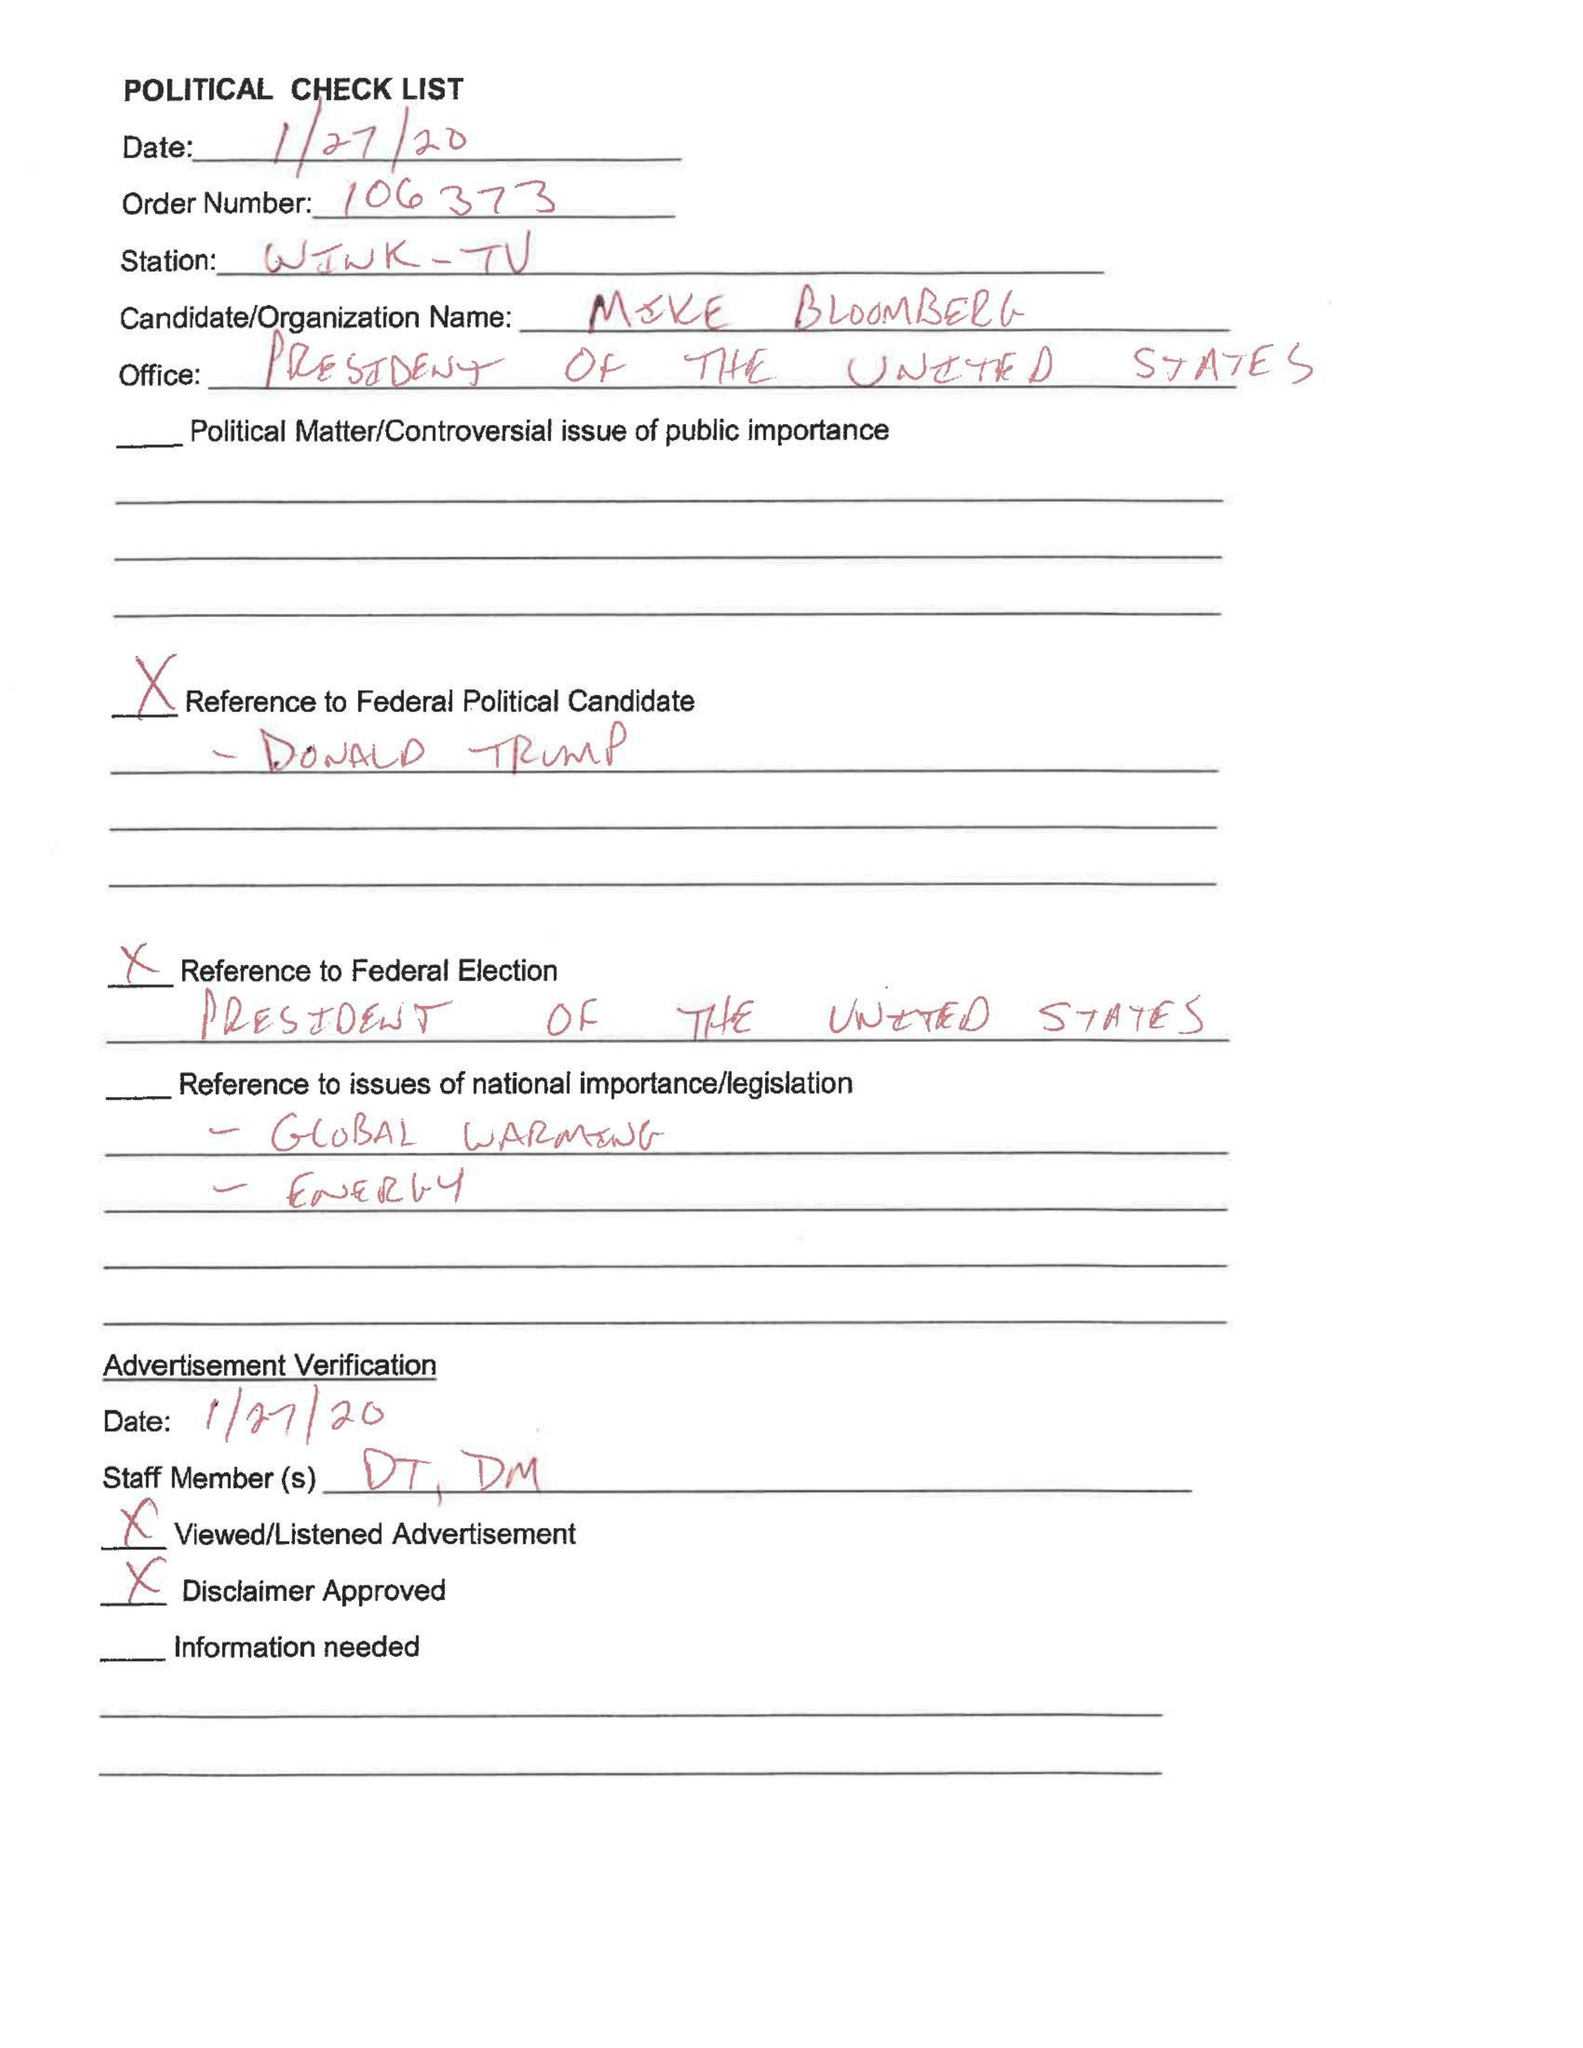What is the value for the gross_amount?
Answer the question using a single word or phrase. None 